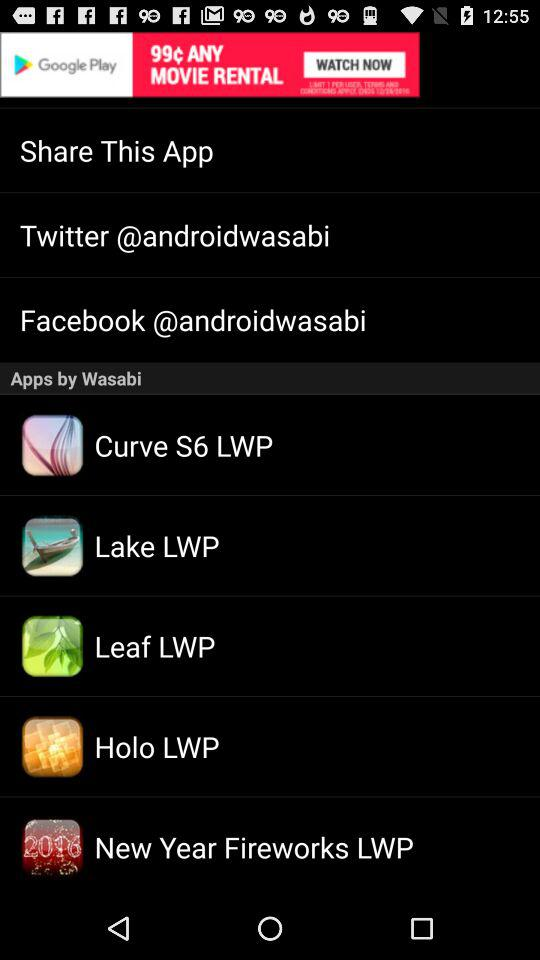Which applications are available for sharing this application?
When the provided information is insufficient, respond with <no answer>. <no answer> 